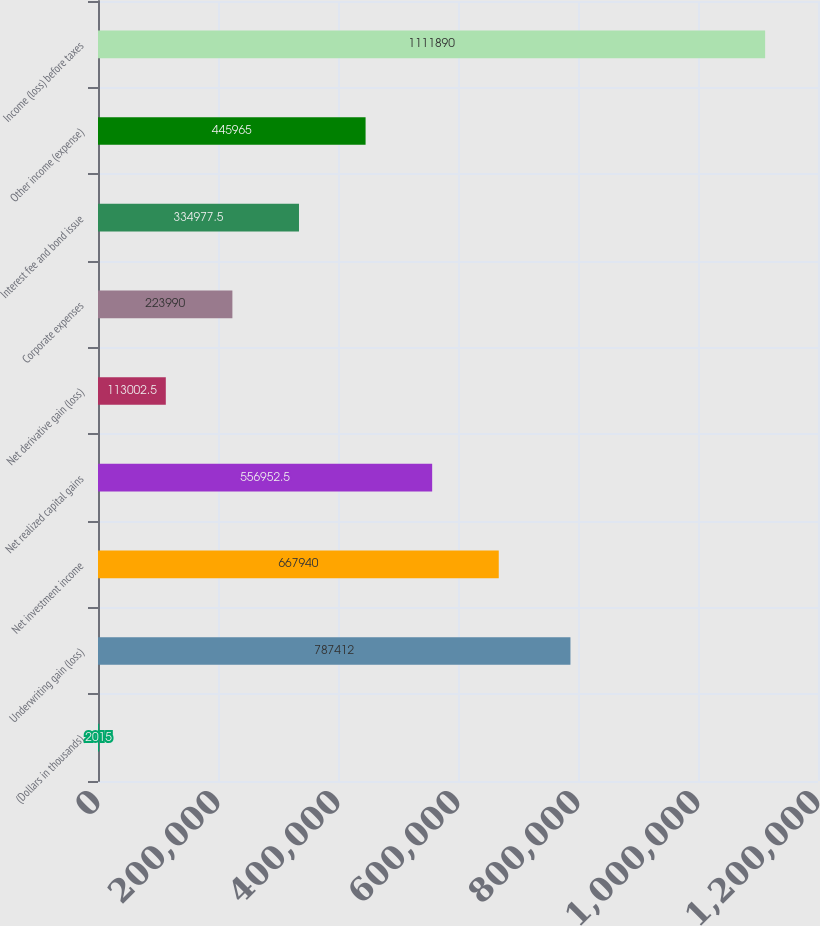Convert chart to OTSL. <chart><loc_0><loc_0><loc_500><loc_500><bar_chart><fcel>(Dollars in thousands)<fcel>Underwriting gain (loss)<fcel>Net investment income<fcel>Net realized capital gains<fcel>Net derivative gain (loss)<fcel>Corporate expenses<fcel>Interest fee and bond issue<fcel>Other income (expense)<fcel>Income (loss) before taxes<nl><fcel>2015<fcel>787412<fcel>667940<fcel>556952<fcel>113002<fcel>223990<fcel>334978<fcel>445965<fcel>1.11189e+06<nl></chart> 